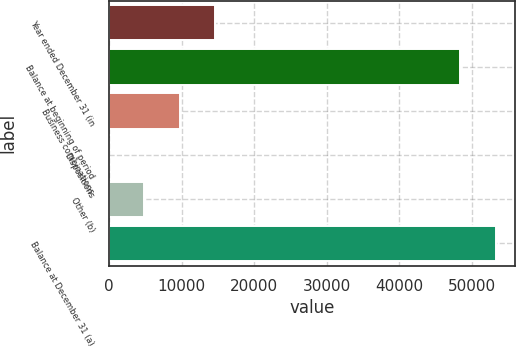Convert chart to OTSL. <chart><loc_0><loc_0><loc_500><loc_500><bar_chart><fcel>Year ended December 31 (in<fcel>Balance at beginning of period<fcel>Business combinations<fcel>Dispositions<fcel>Other (b)<fcel>Balance at December 31 (a)<nl><fcel>14669.5<fcel>48357<fcel>9786<fcel>19<fcel>4902.5<fcel>53240.5<nl></chart> 